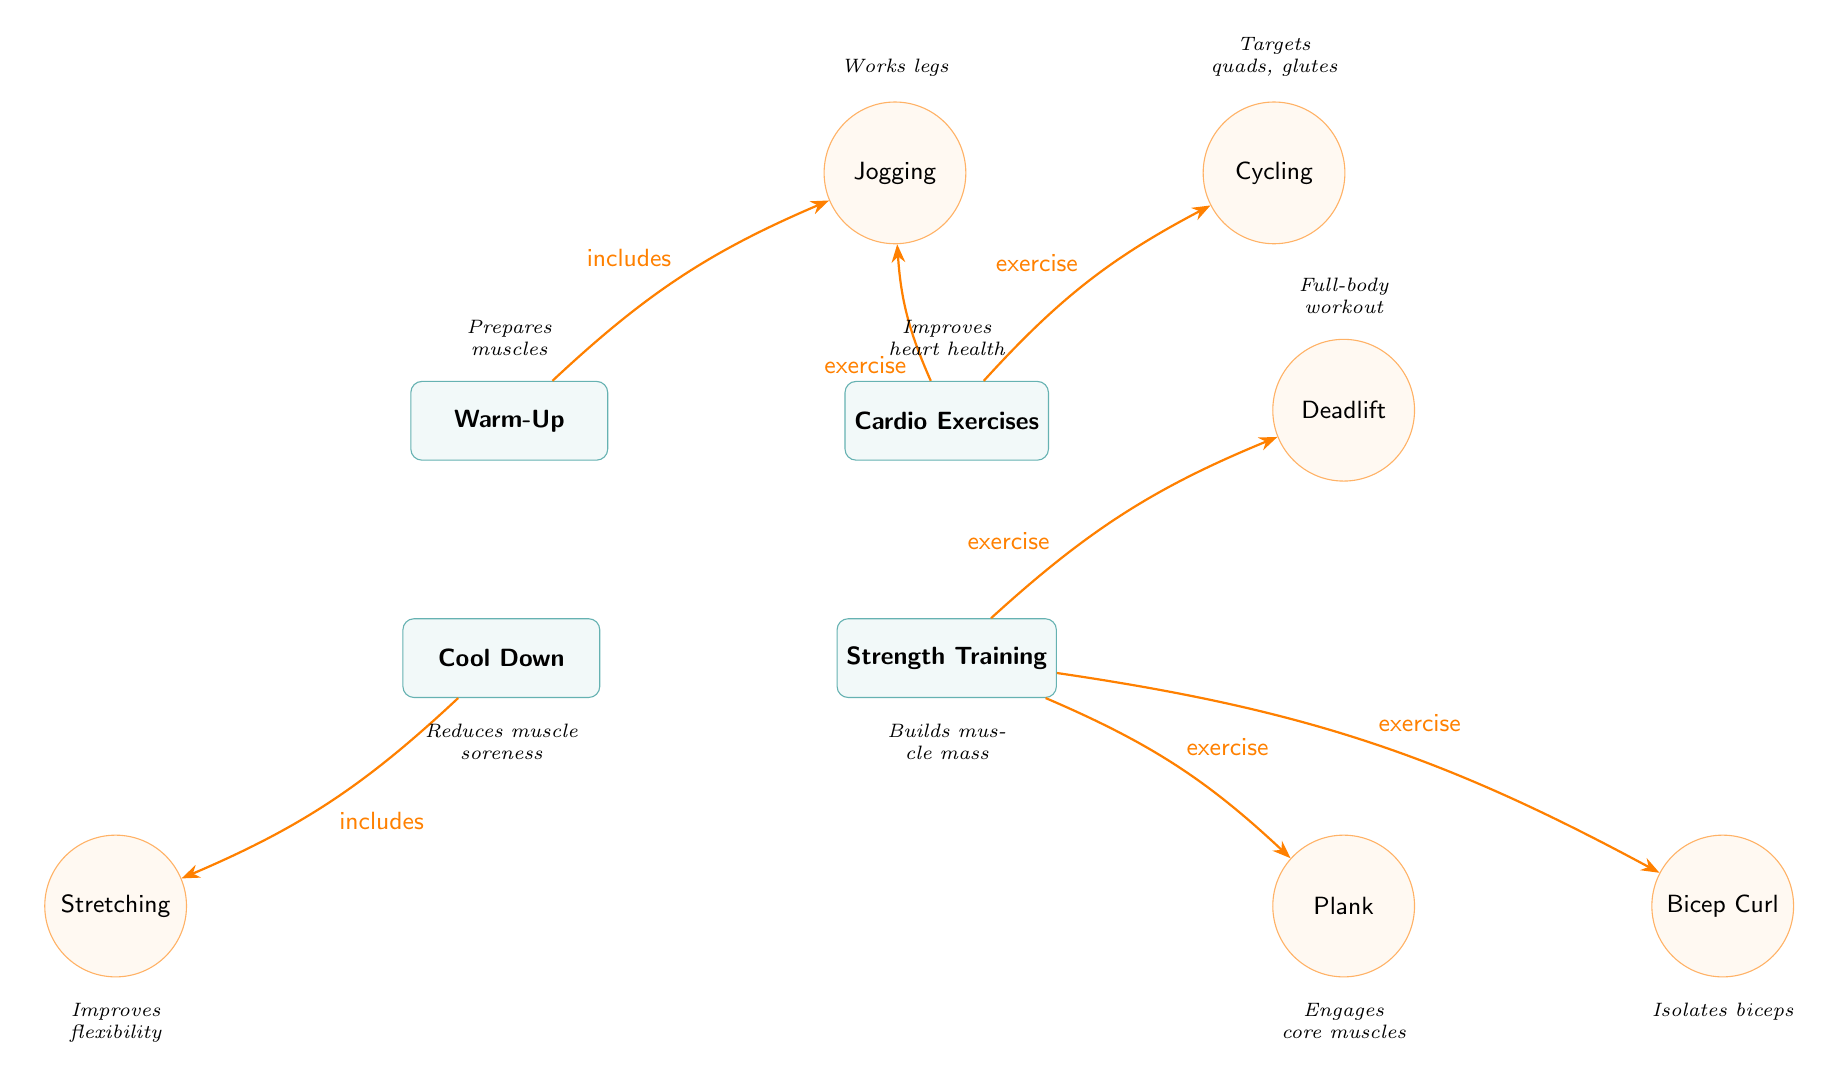What are the main categories in the diagram? The diagram includes four main categories: Warm-Up, Cardio Exercises, Strength Training, and Cool Down. These are clearly displayed as the primary sections with each category represented by a rectangle.
Answer: Warm-Up, Cardio Exercises, Strength Training, Cool Down Which exercise is included under the Warm-Up category? The diagram indicates that Jogging is an exercise included under the Warm-Up category, as shown by the arrow connecting Warm-Up to Jogging.
Answer: Jogging What muscle group does Cycling primarily target? The diagram specifies that Cycling targets the quads and glutes, which is provided as a description beneath the Cycling exercise node.
Answer: Quads, glutes How many exercises are listed under Strength Training? In the diagram, there are three exercises listed under Strength Training: Plank, Bicep Curl, and Deadlift. The connections show these three exercises relating to the Strength Training category.
Answer: Three Which category includes Stretching? Stretching is included in the Cool Down category, as indicated by the arrow from Cool Down to Stretching in the diagram.
Answer: Cool Down What improvement does the Cool Down category provide? The diagram describes that the Cool Down category reduces muscle soreness, which is explicitly stated beneath the Cool Down node.
Answer: Reduces muscle soreness Which exercise in Strength Training engages core muscles? The Plank exercise engages core muscles, which is noted in the description directly beneath the Plank node.
Answer: Plank What is the function of the Warm-Up category? The diagram shows that the Warm-Up category prepares muscles, as indicated in the description below the Warm-Up node.
Answer: Prepares muscles What type of workout does the Deadlift represent? The Deadlift exercise is described as a full-body workout, which is stated beneath the Deadlift node in the diagram.
Answer: Full-body workout 